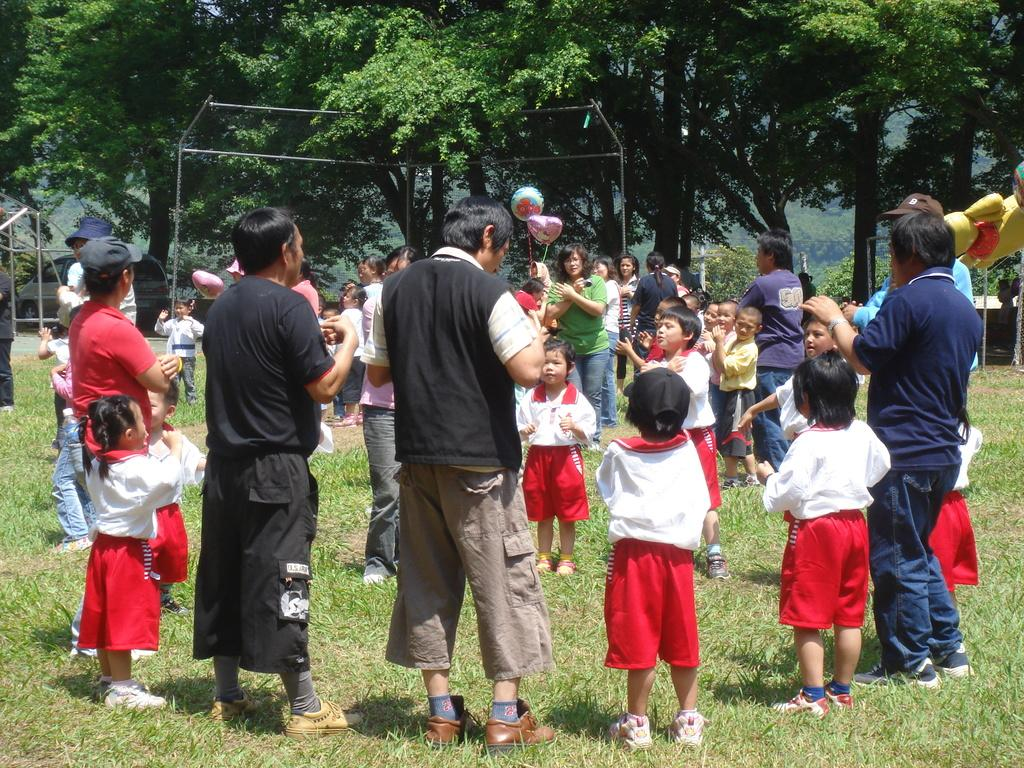How many individuals are present in the image? There are many people in the image. Can you identify any specific age groups among the people in the image? Yes, there are children in the image. What type of terrain is visible in the image? There is grass on the ground in the image. What can be seen in the background of the image? There are trees in the background of the image. What additional objects are present in the image? There are balloons in the image. What type of nut is being used to fold the details in the image? There is no nut or folding activity present in the image. The image features people, children, grass, trees, and balloons, but no nuts or folding. 